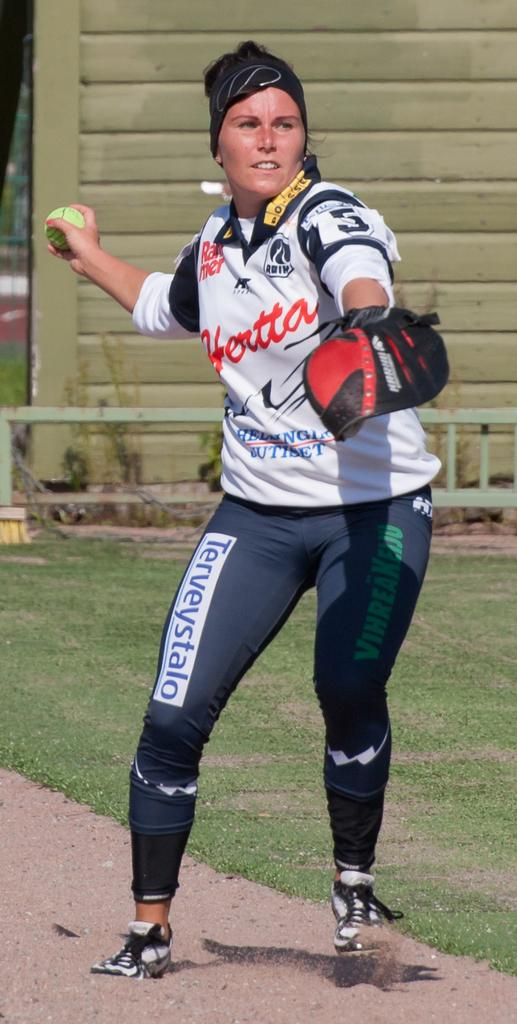<image>
Relay a brief, clear account of the picture shown. A woman in softball gear including a pair of Terveystalo leggings. 